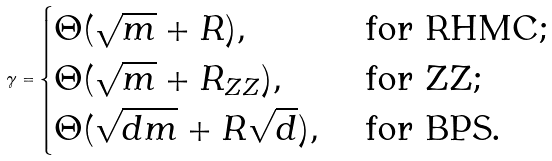Convert formula to latex. <formula><loc_0><loc_0><loc_500><loc_500>\gamma = \begin{cases} \Theta ( \sqrt { m } + R ) , & \text { for RHMC;} \\ \Theta ( \sqrt { m } + R _ { Z Z } ) , & \text { for ZZ;} \\ \Theta ( \sqrt { d m } + R \sqrt { d } ) , & \text { for BPS.} \end{cases}</formula> 